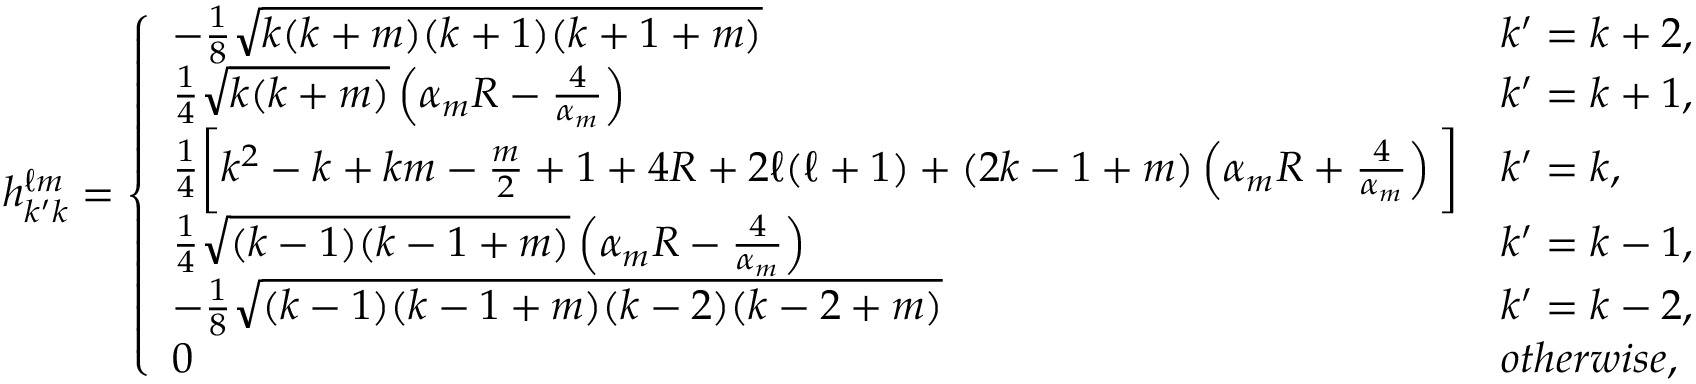Convert formula to latex. <formula><loc_0><loc_0><loc_500><loc_500>h _ { k ^ { \prime } k } ^ { \ell m } = \left \{ \begin{array} { l l } { - \frac { 1 } { 8 } \sqrt { k ( k + m ) ( k + 1 ) ( k + 1 + m ) } } & { k ^ { \prime } = k + 2 , } \\ { \frac { 1 } { 4 } \sqrt { k ( k + m ) } \left ( \alpha _ { m } R - \frac { 4 } { \alpha _ { m } } \right ) } & { k ^ { \prime } = k + 1 , } \\ { \frac { 1 } { 4 } \left [ k ^ { 2 } - k + k m - \frac { m } { 2 } + 1 + 4 R + 2 \ell ( \ell + 1 ) + ( 2 k - 1 + m ) \left ( \alpha _ { m } R + \frac { 4 } { \alpha _ { m } } \right ) \right ] } & { k ^ { \prime } = k , } \\ { \frac { 1 } { 4 } \sqrt { ( k - 1 ) ( k - 1 + m ) } \left ( \alpha _ { m } R - \frac { 4 } { \alpha _ { m } } \right ) } & { k ^ { \prime } = k - 1 , } \\ { - \frac { 1 } { 8 } \sqrt { ( k - 1 ) ( k - 1 + m ) ( k - 2 ) ( k - 2 + m ) } } & { k ^ { \prime } = k - 2 , } \\ { 0 } & { o t h e r w i s e , } \end{array}</formula> 